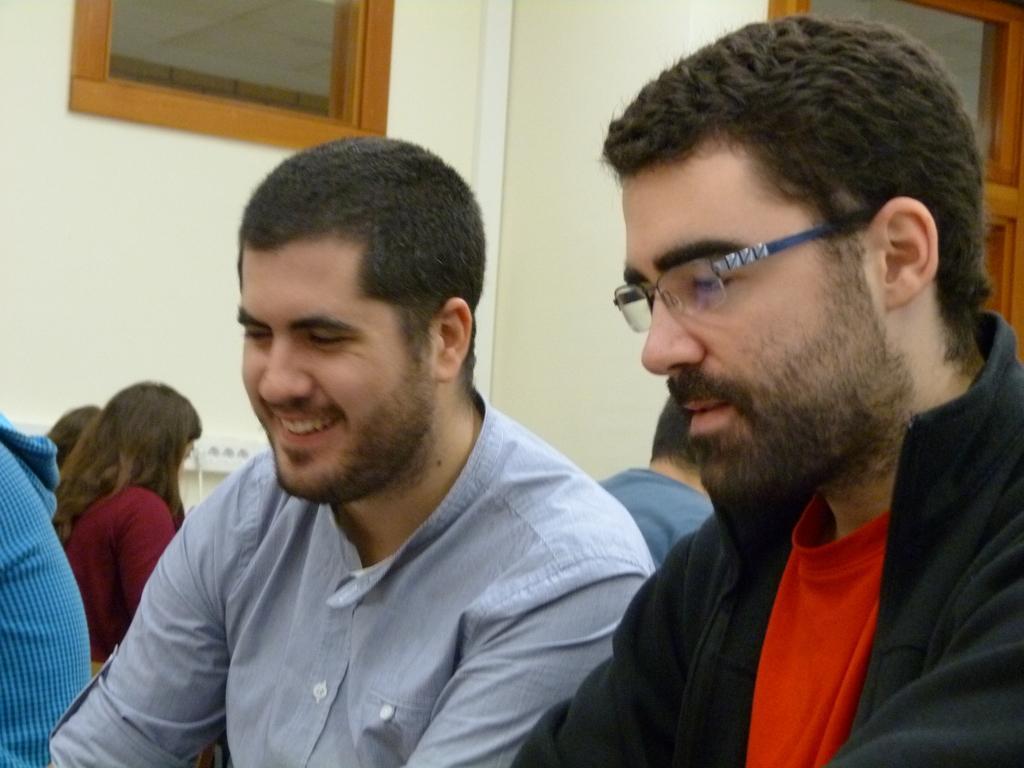Can you describe this image briefly? In this image in the foreground there are two persons one person, is wearing spectacles and one person is smiling. And in the background there are some people, and there is a switchboard, window, wall, and on the right side of the image there might be a door. 